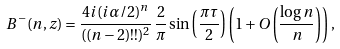Convert formula to latex. <formula><loc_0><loc_0><loc_500><loc_500>B ^ { - } ( n , z ) = \frac { 4 i ( i \alpha / 2 ) ^ { n } } { ( ( n - 2 ) ! ! ) ^ { 2 } } \, \frac { 2 } { \pi } \sin \left ( \frac { \pi \tau } { 2 } \right ) \left ( 1 + O \left ( \frac { \log n } { n } \right ) \right ) ,</formula> 